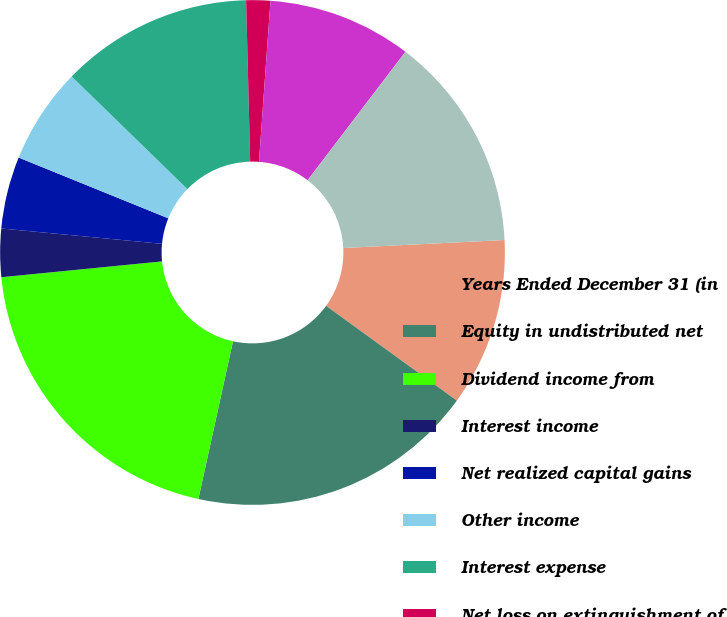Convert chart. <chart><loc_0><loc_0><loc_500><loc_500><pie_chart><fcel>Years Ended December 31 (in<fcel>Equity in undistributed net<fcel>Dividend income from<fcel>Interest income<fcel>Net realized capital gains<fcel>Other income<fcel>Interest expense<fcel>Net loss on extinguishment of<fcel>Other expenses<fcel>Income from continuing<nl><fcel>10.77%<fcel>18.46%<fcel>20.0%<fcel>3.08%<fcel>4.62%<fcel>6.15%<fcel>12.31%<fcel>1.54%<fcel>9.23%<fcel>13.85%<nl></chart> 